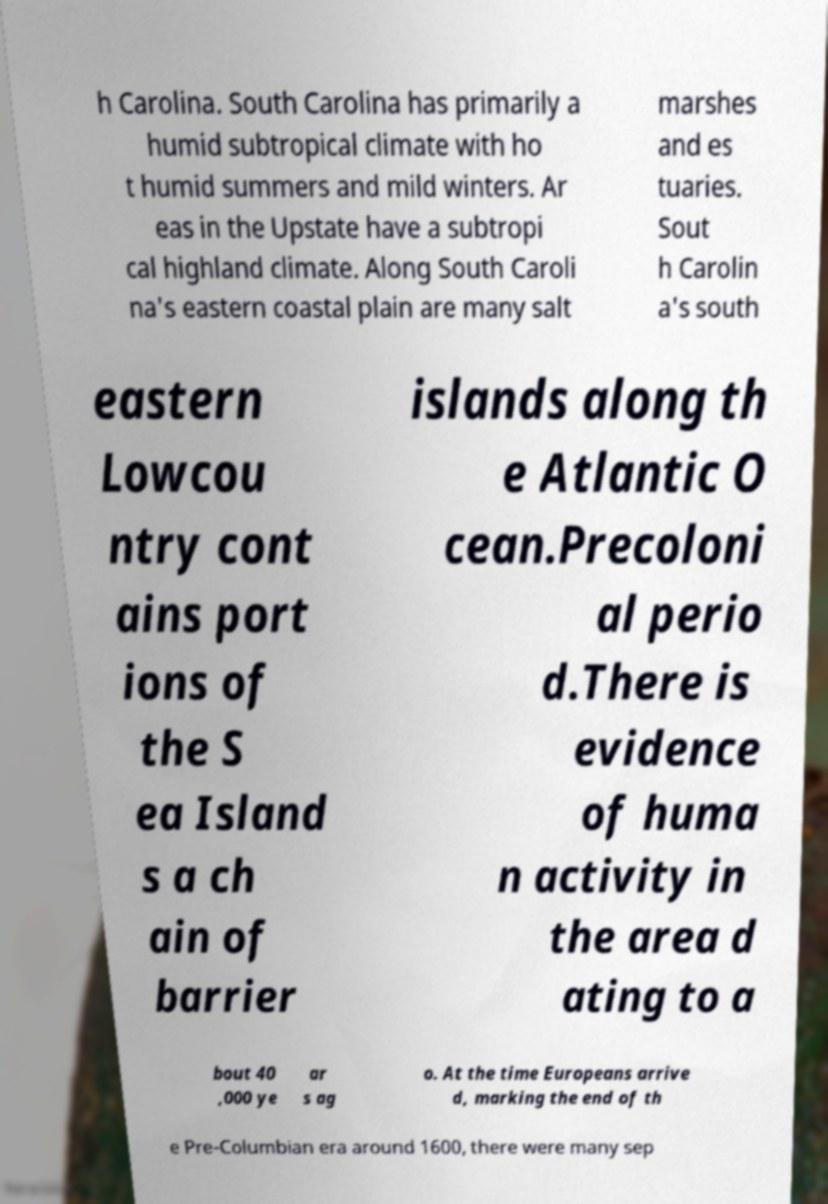For documentation purposes, I need the text within this image transcribed. Could you provide that? h Carolina. South Carolina has primarily a humid subtropical climate with ho t humid summers and mild winters. Ar eas in the Upstate have a subtropi cal highland climate. Along South Caroli na's eastern coastal plain are many salt marshes and es tuaries. Sout h Carolin a's south eastern Lowcou ntry cont ains port ions of the S ea Island s a ch ain of barrier islands along th e Atlantic O cean.Precoloni al perio d.There is evidence of huma n activity in the area d ating to a bout 40 ,000 ye ar s ag o. At the time Europeans arrive d, marking the end of th e Pre-Columbian era around 1600, there were many sep 